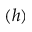Convert formula to latex. <formula><loc_0><loc_0><loc_500><loc_500>( h )</formula> 